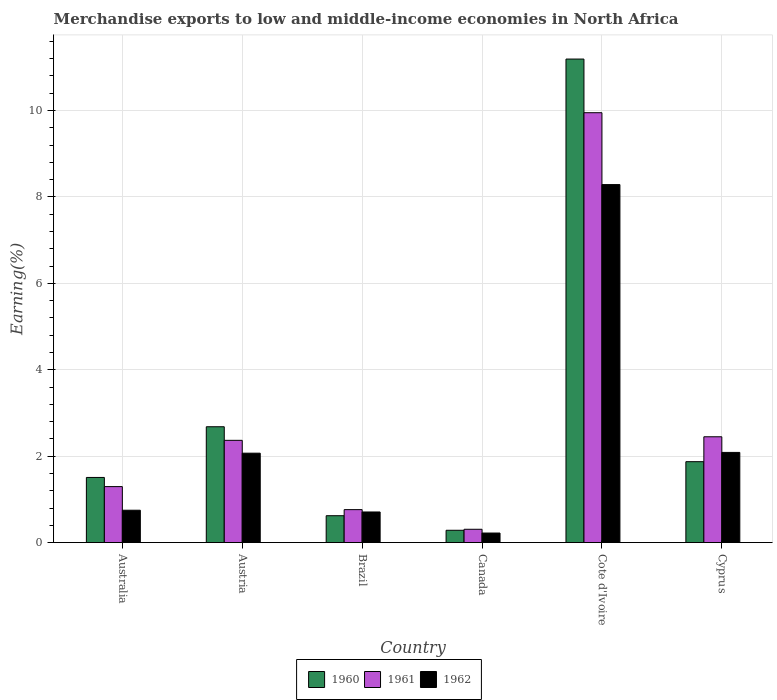How many different coloured bars are there?
Keep it short and to the point. 3. How many groups of bars are there?
Your answer should be very brief. 6. Are the number of bars per tick equal to the number of legend labels?
Your response must be concise. Yes. How many bars are there on the 5th tick from the right?
Provide a succinct answer. 3. What is the label of the 6th group of bars from the left?
Make the answer very short. Cyprus. What is the percentage of amount earned from merchandise exports in 1960 in Brazil?
Your answer should be compact. 0.62. Across all countries, what is the maximum percentage of amount earned from merchandise exports in 1960?
Provide a short and direct response. 11.19. Across all countries, what is the minimum percentage of amount earned from merchandise exports in 1961?
Provide a succinct answer. 0.31. In which country was the percentage of amount earned from merchandise exports in 1961 maximum?
Your answer should be very brief. Cote d'Ivoire. In which country was the percentage of amount earned from merchandise exports in 1962 minimum?
Provide a succinct answer. Canada. What is the total percentage of amount earned from merchandise exports in 1960 in the graph?
Offer a very short reply. 18.16. What is the difference between the percentage of amount earned from merchandise exports in 1961 in Canada and that in Cote d'Ivoire?
Your answer should be compact. -9.64. What is the difference between the percentage of amount earned from merchandise exports in 1962 in Cyprus and the percentage of amount earned from merchandise exports in 1960 in Austria?
Your answer should be compact. -0.59. What is the average percentage of amount earned from merchandise exports in 1960 per country?
Give a very brief answer. 3.03. What is the difference between the percentage of amount earned from merchandise exports of/in 1962 and percentage of amount earned from merchandise exports of/in 1960 in Cyprus?
Provide a short and direct response. 0.21. In how many countries, is the percentage of amount earned from merchandise exports in 1961 greater than 4.4 %?
Provide a short and direct response. 1. What is the ratio of the percentage of amount earned from merchandise exports in 1961 in Brazil to that in Cyprus?
Offer a very short reply. 0.31. Is the percentage of amount earned from merchandise exports in 1962 in Austria less than that in Canada?
Ensure brevity in your answer.  No. What is the difference between the highest and the second highest percentage of amount earned from merchandise exports in 1961?
Offer a terse response. 7.5. What is the difference between the highest and the lowest percentage of amount earned from merchandise exports in 1961?
Give a very brief answer. 9.64. In how many countries, is the percentage of amount earned from merchandise exports in 1961 greater than the average percentage of amount earned from merchandise exports in 1961 taken over all countries?
Offer a very short reply. 1. Is the sum of the percentage of amount earned from merchandise exports in 1961 in Cote d'Ivoire and Cyprus greater than the maximum percentage of amount earned from merchandise exports in 1962 across all countries?
Your answer should be compact. Yes. What does the 1st bar from the left in Australia represents?
Provide a short and direct response. 1960. What does the 3rd bar from the right in Brazil represents?
Your answer should be compact. 1960. Are all the bars in the graph horizontal?
Your response must be concise. No. How many countries are there in the graph?
Your response must be concise. 6. Are the values on the major ticks of Y-axis written in scientific E-notation?
Your response must be concise. No. Does the graph contain grids?
Provide a succinct answer. Yes. Where does the legend appear in the graph?
Offer a very short reply. Bottom center. What is the title of the graph?
Provide a short and direct response. Merchandise exports to low and middle-income economies in North Africa. Does "1987" appear as one of the legend labels in the graph?
Give a very brief answer. No. What is the label or title of the X-axis?
Your answer should be very brief. Country. What is the label or title of the Y-axis?
Keep it short and to the point. Earning(%). What is the Earning(%) of 1960 in Australia?
Make the answer very short. 1.51. What is the Earning(%) of 1961 in Australia?
Provide a short and direct response. 1.3. What is the Earning(%) of 1962 in Australia?
Offer a very short reply. 0.75. What is the Earning(%) of 1960 in Austria?
Your response must be concise. 2.68. What is the Earning(%) in 1961 in Austria?
Make the answer very short. 2.37. What is the Earning(%) of 1962 in Austria?
Make the answer very short. 2.07. What is the Earning(%) of 1960 in Brazil?
Your answer should be compact. 0.62. What is the Earning(%) in 1961 in Brazil?
Your response must be concise. 0.76. What is the Earning(%) in 1962 in Brazil?
Your answer should be very brief. 0.71. What is the Earning(%) in 1960 in Canada?
Provide a succinct answer. 0.28. What is the Earning(%) in 1961 in Canada?
Keep it short and to the point. 0.31. What is the Earning(%) in 1962 in Canada?
Your response must be concise. 0.22. What is the Earning(%) of 1960 in Cote d'Ivoire?
Your answer should be compact. 11.19. What is the Earning(%) in 1961 in Cote d'Ivoire?
Offer a very short reply. 9.95. What is the Earning(%) of 1962 in Cote d'Ivoire?
Provide a succinct answer. 8.29. What is the Earning(%) of 1960 in Cyprus?
Provide a succinct answer. 1.87. What is the Earning(%) of 1961 in Cyprus?
Your response must be concise. 2.45. What is the Earning(%) of 1962 in Cyprus?
Give a very brief answer. 2.09. Across all countries, what is the maximum Earning(%) of 1960?
Provide a succinct answer. 11.19. Across all countries, what is the maximum Earning(%) of 1961?
Make the answer very short. 9.95. Across all countries, what is the maximum Earning(%) of 1962?
Keep it short and to the point. 8.29. Across all countries, what is the minimum Earning(%) in 1960?
Ensure brevity in your answer.  0.28. Across all countries, what is the minimum Earning(%) of 1961?
Offer a very short reply. 0.31. Across all countries, what is the minimum Earning(%) in 1962?
Give a very brief answer. 0.22. What is the total Earning(%) of 1960 in the graph?
Make the answer very short. 18.16. What is the total Earning(%) of 1961 in the graph?
Ensure brevity in your answer.  17.13. What is the total Earning(%) in 1962 in the graph?
Provide a succinct answer. 14.12. What is the difference between the Earning(%) of 1960 in Australia and that in Austria?
Keep it short and to the point. -1.17. What is the difference between the Earning(%) of 1961 in Australia and that in Austria?
Ensure brevity in your answer.  -1.07. What is the difference between the Earning(%) of 1962 in Australia and that in Austria?
Offer a terse response. -1.32. What is the difference between the Earning(%) in 1960 in Australia and that in Brazil?
Keep it short and to the point. 0.89. What is the difference between the Earning(%) of 1961 in Australia and that in Brazil?
Your answer should be compact. 0.53. What is the difference between the Earning(%) in 1962 in Australia and that in Brazil?
Your response must be concise. 0.04. What is the difference between the Earning(%) in 1960 in Australia and that in Canada?
Your answer should be compact. 1.22. What is the difference between the Earning(%) in 1961 in Australia and that in Canada?
Ensure brevity in your answer.  0.99. What is the difference between the Earning(%) of 1962 in Australia and that in Canada?
Ensure brevity in your answer.  0.53. What is the difference between the Earning(%) in 1960 in Australia and that in Cote d'Ivoire?
Your answer should be compact. -9.68. What is the difference between the Earning(%) of 1961 in Australia and that in Cote d'Ivoire?
Offer a very short reply. -8.65. What is the difference between the Earning(%) of 1962 in Australia and that in Cote d'Ivoire?
Offer a terse response. -7.54. What is the difference between the Earning(%) of 1960 in Australia and that in Cyprus?
Offer a terse response. -0.36. What is the difference between the Earning(%) in 1961 in Australia and that in Cyprus?
Offer a very short reply. -1.15. What is the difference between the Earning(%) in 1962 in Australia and that in Cyprus?
Your response must be concise. -1.34. What is the difference between the Earning(%) of 1960 in Austria and that in Brazil?
Give a very brief answer. 2.06. What is the difference between the Earning(%) in 1961 in Austria and that in Brazil?
Your response must be concise. 1.6. What is the difference between the Earning(%) in 1962 in Austria and that in Brazil?
Make the answer very short. 1.36. What is the difference between the Earning(%) in 1960 in Austria and that in Canada?
Your answer should be compact. 2.4. What is the difference between the Earning(%) of 1961 in Austria and that in Canada?
Your answer should be compact. 2.06. What is the difference between the Earning(%) in 1962 in Austria and that in Canada?
Ensure brevity in your answer.  1.85. What is the difference between the Earning(%) in 1960 in Austria and that in Cote d'Ivoire?
Your response must be concise. -8.51. What is the difference between the Earning(%) of 1961 in Austria and that in Cote d'Ivoire?
Your response must be concise. -7.58. What is the difference between the Earning(%) of 1962 in Austria and that in Cote d'Ivoire?
Offer a very short reply. -6.22. What is the difference between the Earning(%) in 1960 in Austria and that in Cyprus?
Provide a short and direct response. 0.81. What is the difference between the Earning(%) of 1961 in Austria and that in Cyprus?
Ensure brevity in your answer.  -0.08. What is the difference between the Earning(%) in 1962 in Austria and that in Cyprus?
Offer a very short reply. -0.02. What is the difference between the Earning(%) of 1960 in Brazil and that in Canada?
Provide a succinct answer. 0.34. What is the difference between the Earning(%) of 1961 in Brazil and that in Canada?
Ensure brevity in your answer.  0.45. What is the difference between the Earning(%) in 1962 in Brazil and that in Canada?
Keep it short and to the point. 0.49. What is the difference between the Earning(%) of 1960 in Brazil and that in Cote d'Ivoire?
Your answer should be very brief. -10.57. What is the difference between the Earning(%) of 1961 in Brazil and that in Cote d'Ivoire?
Keep it short and to the point. -9.19. What is the difference between the Earning(%) of 1962 in Brazil and that in Cote d'Ivoire?
Make the answer very short. -7.58. What is the difference between the Earning(%) of 1960 in Brazil and that in Cyprus?
Make the answer very short. -1.25. What is the difference between the Earning(%) in 1961 in Brazil and that in Cyprus?
Your response must be concise. -1.69. What is the difference between the Earning(%) in 1962 in Brazil and that in Cyprus?
Your answer should be compact. -1.38. What is the difference between the Earning(%) of 1960 in Canada and that in Cote d'Ivoire?
Your answer should be very brief. -10.91. What is the difference between the Earning(%) of 1961 in Canada and that in Cote d'Ivoire?
Offer a very short reply. -9.64. What is the difference between the Earning(%) of 1962 in Canada and that in Cote d'Ivoire?
Your answer should be very brief. -8.06. What is the difference between the Earning(%) in 1960 in Canada and that in Cyprus?
Ensure brevity in your answer.  -1.59. What is the difference between the Earning(%) in 1961 in Canada and that in Cyprus?
Ensure brevity in your answer.  -2.14. What is the difference between the Earning(%) of 1962 in Canada and that in Cyprus?
Make the answer very short. -1.87. What is the difference between the Earning(%) in 1960 in Cote d'Ivoire and that in Cyprus?
Give a very brief answer. 9.32. What is the difference between the Earning(%) in 1961 in Cote d'Ivoire and that in Cyprus?
Keep it short and to the point. 7.5. What is the difference between the Earning(%) in 1962 in Cote d'Ivoire and that in Cyprus?
Provide a short and direct response. 6.2. What is the difference between the Earning(%) in 1960 in Australia and the Earning(%) in 1961 in Austria?
Provide a succinct answer. -0.86. What is the difference between the Earning(%) of 1960 in Australia and the Earning(%) of 1962 in Austria?
Provide a short and direct response. -0.56. What is the difference between the Earning(%) in 1961 in Australia and the Earning(%) in 1962 in Austria?
Offer a terse response. -0.77. What is the difference between the Earning(%) of 1960 in Australia and the Earning(%) of 1961 in Brazil?
Ensure brevity in your answer.  0.74. What is the difference between the Earning(%) of 1960 in Australia and the Earning(%) of 1962 in Brazil?
Make the answer very short. 0.8. What is the difference between the Earning(%) in 1961 in Australia and the Earning(%) in 1962 in Brazil?
Provide a short and direct response. 0.59. What is the difference between the Earning(%) of 1960 in Australia and the Earning(%) of 1961 in Canada?
Offer a terse response. 1.2. What is the difference between the Earning(%) in 1960 in Australia and the Earning(%) in 1962 in Canada?
Your response must be concise. 1.29. What is the difference between the Earning(%) in 1961 in Australia and the Earning(%) in 1962 in Canada?
Provide a short and direct response. 1.07. What is the difference between the Earning(%) in 1960 in Australia and the Earning(%) in 1961 in Cote d'Ivoire?
Your answer should be very brief. -8.44. What is the difference between the Earning(%) in 1960 in Australia and the Earning(%) in 1962 in Cote d'Ivoire?
Make the answer very short. -6.78. What is the difference between the Earning(%) of 1961 in Australia and the Earning(%) of 1962 in Cote d'Ivoire?
Keep it short and to the point. -6.99. What is the difference between the Earning(%) in 1960 in Australia and the Earning(%) in 1961 in Cyprus?
Your response must be concise. -0.94. What is the difference between the Earning(%) in 1960 in Australia and the Earning(%) in 1962 in Cyprus?
Offer a terse response. -0.58. What is the difference between the Earning(%) of 1961 in Australia and the Earning(%) of 1962 in Cyprus?
Offer a terse response. -0.79. What is the difference between the Earning(%) in 1960 in Austria and the Earning(%) in 1961 in Brazil?
Ensure brevity in your answer.  1.92. What is the difference between the Earning(%) in 1960 in Austria and the Earning(%) in 1962 in Brazil?
Your answer should be compact. 1.97. What is the difference between the Earning(%) of 1961 in Austria and the Earning(%) of 1962 in Brazil?
Keep it short and to the point. 1.66. What is the difference between the Earning(%) in 1960 in Austria and the Earning(%) in 1961 in Canada?
Provide a short and direct response. 2.37. What is the difference between the Earning(%) of 1960 in Austria and the Earning(%) of 1962 in Canada?
Give a very brief answer. 2.46. What is the difference between the Earning(%) in 1961 in Austria and the Earning(%) in 1962 in Canada?
Offer a terse response. 2.15. What is the difference between the Earning(%) of 1960 in Austria and the Earning(%) of 1961 in Cote d'Ivoire?
Give a very brief answer. -7.27. What is the difference between the Earning(%) in 1960 in Austria and the Earning(%) in 1962 in Cote d'Ivoire?
Provide a short and direct response. -5.6. What is the difference between the Earning(%) of 1961 in Austria and the Earning(%) of 1962 in Cote d'Ivoire?
Your response must be concise. -5.92. What is the difference between the Earning(%) in 1960 in Austria and the Earning(%) in 1961 in Cyprus?
Offer a terse response. 0.23. What is the difference between the Earning(%) in 1960 in Austria and the Earning(%) in 1962 in Cyprus?
Offer a terse response. 0.59. What is the difference between the Earning(%) of 1961 in Austria and the Earning(%) of 1962 in Cyprus?
Your answer should be very brief. 0.28. What is the difference between the Earning(%) of 1960 in Brazil and the Earning(%) of 1961 in Canada?
Provide a short and direct response. 0.31. What is the difference between the Earning(%) in 1960 in Brazil and the Earning(%) in 1962 in Canada?
Your answer should be very brief. 0.4. What is the difference between the Earning(%) in 1961 in Brazil and the Earning(%) in 1962 in Canada?
Your answer should be compact. 0.54. What is the difference between the Earning(%) in 1960 in Brazil and the Earning(%) in 1961 in Cote d'Ivoire?
Give a very brief answer. -9.33. What is the difference between the Earning(%) of 1960 in Brazil and the Earning(%) of 1962 in Cote d'Ivoire?
Provide a succinct answer. -7.66. What is the difference between the Earning(%) in 1961 in Brazil and the Earning(%) in 1962 in Cote d'Ivoire?
Keep it short and to the point. -7.52. What is the difference between the Earning(%) in 1960 in Brazil and the Earning(%) in 1961 in Cyprus?
Your response must be concise. -1.83. What is the difference between the Earning(%) of 1960 in Brazil and the Earning(%) of 1962 in Cyprus?
Provide a short and direct response. -1.46. What is the difference between the Earning(%) in 1961 in Brazil and the Earning(%) in 1962 in Cyprus?
Your answer should be very brief. -1.32. What is the difference between the Earning(%) of 1960 in Canada and the Earning(%) of 1961 in Cote d'Ivoire?
Offer a terse response. -9.66. What is the difference between the Earning(%) of 1960 in Canada and the Earning(%) of 1962 in Cote d'Ivoire?
Your response must be concise. -8. What is the difference between the Earning(%) in 1961 in Canada and the Earning(%) in 1962 in Cote d'Ivoire?
Keep it short and to the point. -7.98. What is the difference between the Earning(%) of 1960 in Canada and the Earning(%) of 1961 in Cyprus?
Offer a very short reply. -2.16. What is the difference between the Earning(%) in 1960 in Canada and the Earning(%) in 1962 in Cyprus?
Give a very brief answer. -1.8. What is the difference between the Earning(%) of 1961 in Canada and the Earning(%) of 1962 in Cyprus?
Your answer should be very brief. -1.78. What is the difference between the Earning(%) of 1960 in Cote d'Ivoire and the Earning(%) of 1961 in Cyprus?
Provide a succinct answer. 8.74. What is the difference between the Earning(%) of 1960 in Cote d'Ivoire and the Earning(%) of 1962 in Cyprus?
Provide a succinct answer. 9.1. What is the difference between the Earning(%) of 1961 in Cote d'Ivoire and the Earning(%) of 1962 in Cyprus?
Provide a short and direct response. 7.86. What is the average Earning(%) in 1960 per country?
Offer a very short reply. 3.03. What is the average Earning(%) of 1961 per country?
Your response must be concise. 2.86. What is the average Earning(%) of 1962 per country?
Give a very brief answer. 2.35. What is the difference between the Earning(%) of 1960 and Earning(%) of 1961 in Australia?
Provide a succinct answer. 0.21. What is the difference between the Earning(%) in 1960 and Earning(%) in 1962 in Australia?
Provide a short and direct response. 0.76. What is the difference between the Earning(%) in 1961 and Earning(%) in 1962 in Australia?
Offer a very short reply. 0.55. What is the difference between the Earning(%) of 1960 and Earning(%) of 1961 in Austria?
Offer a very short reply. 0.31. What is the difference between the Earning(%) in 1960 and Earning(%) in 1962 in Austria?
Your answer should be very brief. 0.61. What is the difference between the Earning(%) of 1961 and Earning(%) of 1962 in Austria?
Offer a very short reply. 0.3. What is the difference between the Earning(%) of 1960 and Earning(%) of 1961 in Brazil?
Offer a very short reply. -0.14. What is the difference between the Earning(%) in 1960 and Earning(%) in 1962 in Brazil?
Make the answer very short. -0.09. What is the difference between the Earning(%) in 1961 and Earning(%) in 1962 in Brazil?
Keep it short and to the point. 0.05. What is the difference between the Earning(%) in 1960 and Earning(%) in 1961 in Canada?
Provide a short and direct response. -0.02. What is the difference between the Earning(%) in 1960 and Earning(%) in 1962 in Canada?
Offer a terse response. 0.06. What is the difference between the Earning(%) of 1961 and Earning(%) of 1962 in Canada?
Offer a very short reply. 0.09. What is the difference between the Earning(%) in 1960 and Earning(%) in 1961 in Cote d'Ivoire?
Offer a very short reply. 1.24. What is the difference between the Earning(%) in 1960 and Earning(%) in 1962 in Cote d'Ivoire?
Make the answer very short. 2.91. What is the difference between the Earning(%) in 1961 and Earning(%) in 1962 in Cote d'Ivoire?
Your answer should be very brief. 1.66. What is the difference between the Earning(%) of 1960 and Earning(%) of 1961 in Cyprus?
Make the answer very short. -0.58. What is the difference between the Earning(%) in 1960 and Earning(%) in 1962 in Cyprus?
Give a very brief answer. -0.21. What is the difference between the Earning(%) in 1961 and Earning(%) in 1962 in Cyprus?
Offer a terse response. 0.36. What is the ratio of the Earning(%) of 1960 in Australia to that in Austria?
Keep it short and to the point. 0.56. What is the ratio of the Earning(%) of 1961 in Australia to that in Austria?
Offer a very short reply. 0.55. What is the ratio of the Earning(%) of 1962 in Australia to that in Austria?
Give a very brief answer. 0.36. What is the ratio of the Earning(%) in 1960 in Australia to that in Brazil?
Offer a very short reply. 2.42. What is the ratio of the Earning(%) in 1961 in Australia to that in Brazil?
Your answer should be very brief. 1.7. What is the ratio of the Earning(%) in 1962 in Australia to that in Brazil?
Make the answer very short. 1.06. What is the ratio of the Earning(%) in 1960 in Australia to that in Canada?
Offer a terse response. 5.29. What is the ratio of the Earning(%) of 1961 in Australia to that in Canada?
Ensure brevity in your answer.  4.21. What is the ratio of the Earning(%) of 1962 in Australia to that in Canada?
Make the answer very short. 3.39. What is the ratio of the Earning(%) of 1960 in Australia to that in Cote d'Ivoire?
Make the answer very short. 0.13. What is the ratio of the Earning(%) in 1961 in Australia to that in Cote d'Ivoire?
Your answer should be compact. 0.13. What is the ratio of the Earning(%) of 1962 in Australia to that in Cote d'Ivoire?
Make the answer very short. 0.09. What is the ratio of the Earning(%) in 1960 in Australia to that in Cyprus?
Keep it short and to the point. 0.81. What is the ratio of the Earning(%) in 1961 in Australia to that in Cyprus?
Ensure brevity in your answer.  0.53. What is the ratio of the Earning(%) of 1962 in Australia to that in Cyprus?
Give a very brief answer. 0.36. What is the ratio of the Earning(%) of 1960 in Austria to that in Brazil?
Your answer should be very brief. 4.31. What is the ratio of the Earning(%) of 1961 in Austria to that in Brazil?
Ensure brevity in your answer.  3.1. What is the ratio of the Earning(%) of 1962 in Austria to that in Brazil?
Make the answer very short. 2.92. What is the ratio of the Earning(%) of 1960 in Austria to that in Canada?
Ensure brevity in your answer.  9.41. What is the ratio of the Earning(%) in 1961 in Austria to that in Canada?
Keep it short and to the point. 7.68. What is the ratio of the Earning(%) in 1962 in Austria to that in Canada?
Offer a terse response. 9.36. What is the ratio of the Earning(%) in 1960 in Austria to that in Cote d'Ivoire?
Provide a succinct answer. 0.24. What is the ratio of the Earning(%) in 1961 in Austria to that in Cote d'Ivoire?
Make the answer very short. 0.24. What is the ratio of the Earning(%) in 1962 in Austria to that in Cote d'Ivoire?
Your answer should be very brief. 0.25. What is the ratio of the Earning(%) in 1960 in Austria to that in Cyprus?
Your response must be concise. 1.43. What is the ratio of the Earning(%) of 1961 in Austria to that in Cyprus?
Your response must be concise. 0.97. What is the ratio of the Earning(%) in 1960 in Brazil to that in Canada?
Keep it short and to the point. 2.18. What is the ratio of the Earning(%) of 1961 in Brazil to that in Canada?
Make the answer very short. 2.48. What is the ratio of the Earning(%) of 1962 in Brazil to that in Canada?
Your answer should be compact. 3.21. What is the ratio of the Earning(%) in 1960 in Brazil to that in Cote d'Ivoire?
Offer a terse response. 0.06. What is the ratio of the Earning(%) in 1961 in Brazil to that in Cote d'Ivoire?
Provide a succinct answer. 0.08. What is the ratio of the Earning(%) in 1962 in Brazil to that in Cote d'Ivoire?
Your response must be concise. 0.09. What is the ratio of the Earning(%) in 1960 in Brazil to that in Cyprus?
Ensure brevity in your answer.  0.33. What is the ratio of the Earning(%) of 1961 in Brazil to that in Cyprus?
Give a very brief answer. 0.31. What is the ratio of the Earning(%) of 1962 in Brazil to that in Cyprus?
Provide a short and direct response. 0.34. What is the ratio of the Earning(%) in 1960 in Canada to that in Cote d'Ivoire?
Make the answer very short. 0.03. What is the ratio of the Earning(%) of 1961 in Canada to that in Cote d'Ivoire?
Offer a terse response. 0.03. What is the ratio of the Earning(%) in 1962 in Canada to that in Cote d'Ivoire?
Make the answer very short. 0.03. What is the ratio of the Earning(%) of 1960 in Canada to that in Cyprus?
Make the answer very short. 0.15. What is the ratio of the Earning(%) in 1961 in Canada to that in Cyprus?
Your answer should be very brief. 0.13. What is the ratio of the Earning(%) in 1962 in Canada to that in Cyprus?
Keep it short and to the point. 0.11. What is the ratio of the Earning(%) of 1960 in Cote d'Ivoire to that in Cyprus?
Offer a very short reply. 5.98. What is the ratio of the Earning(%) in 1961 in Cote d'Ivoire to that in Cyprus?
Keep it short and to the point. 4.06. What is the ratio of the Earning(%) in 1962 in Cote d'Ivoire to that in Cyprus?
Offer a very short reply. 3.97. What is the difference between the highest and the second highest Earning(%) of 1960?
Provide a succinct answer. 8.51. What is the difference between the highest and the second highest Earning(%) in 1961?
Offer a terse response. 7.5. What is the difference between the highest and the second highest Earning(%) in 1962?
Provide a short and direct response. 6.2. What is the difference between the highest and the lowest Earning(%) of 1960?
Provide a succinct answer. 10.91. What is the difference between the highest and the lowest Earning(%) of 1961?
Provide a succinct answer. 9.64. What is the difference between the highest and the lowest Earning(%) of 1962?
Your answer should be compact. 8.06. 